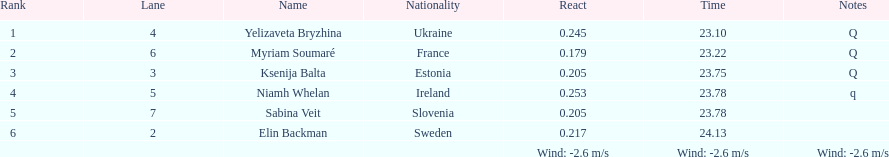The variation between yelizaveta bryzhina's time and ksenija balta's time? 0.65. 